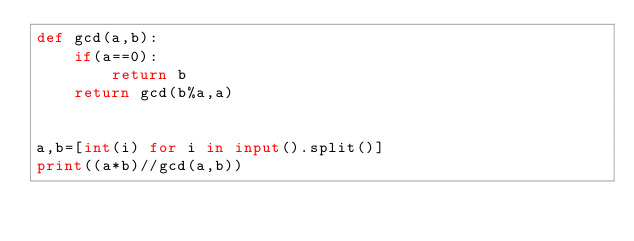<code> <loc_0><loc_0><loc_500><loc_500><_Python_>def gcd(a,b):
    if(a==0):
        return b
    return gcd(b%a,a)


a,b=[int(i) for i in input().split()]
print((a*b)//gcd(a,b))
</code> 